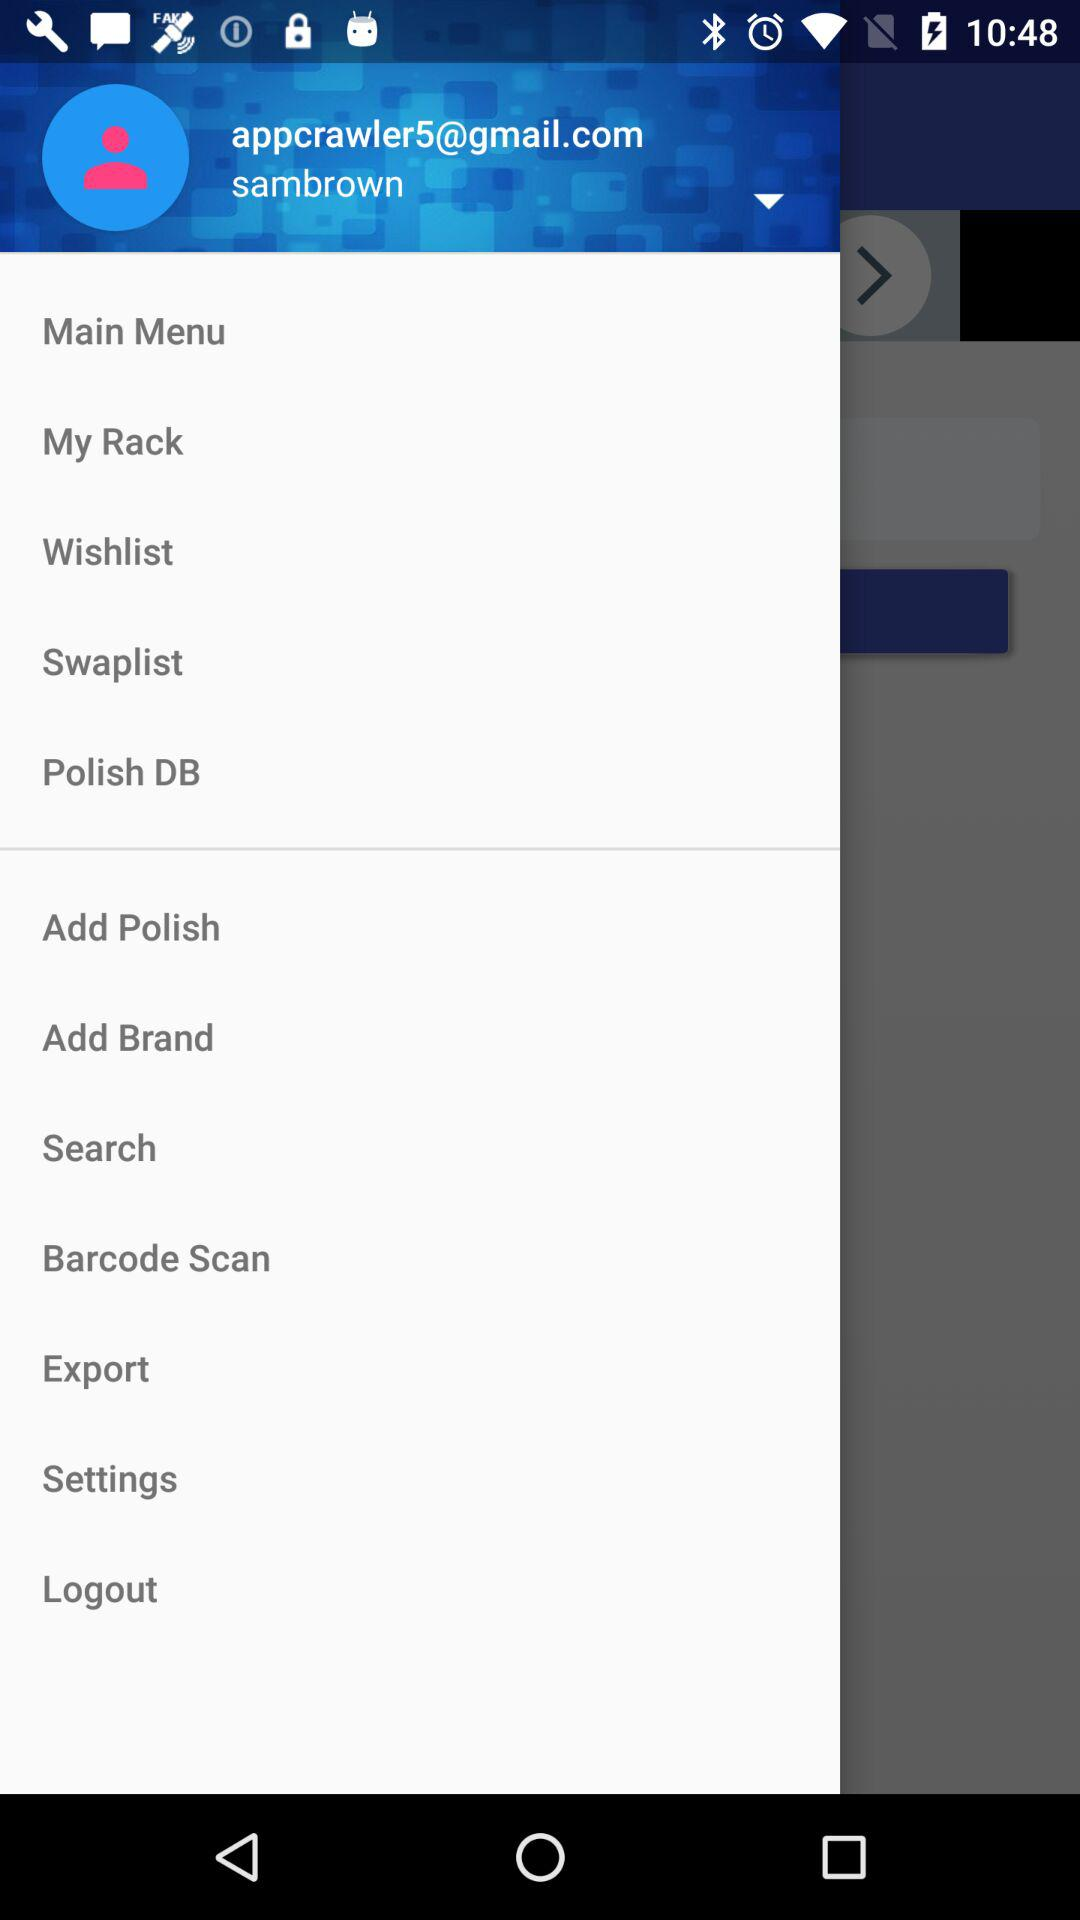What is the username? The username is "sambrown". 